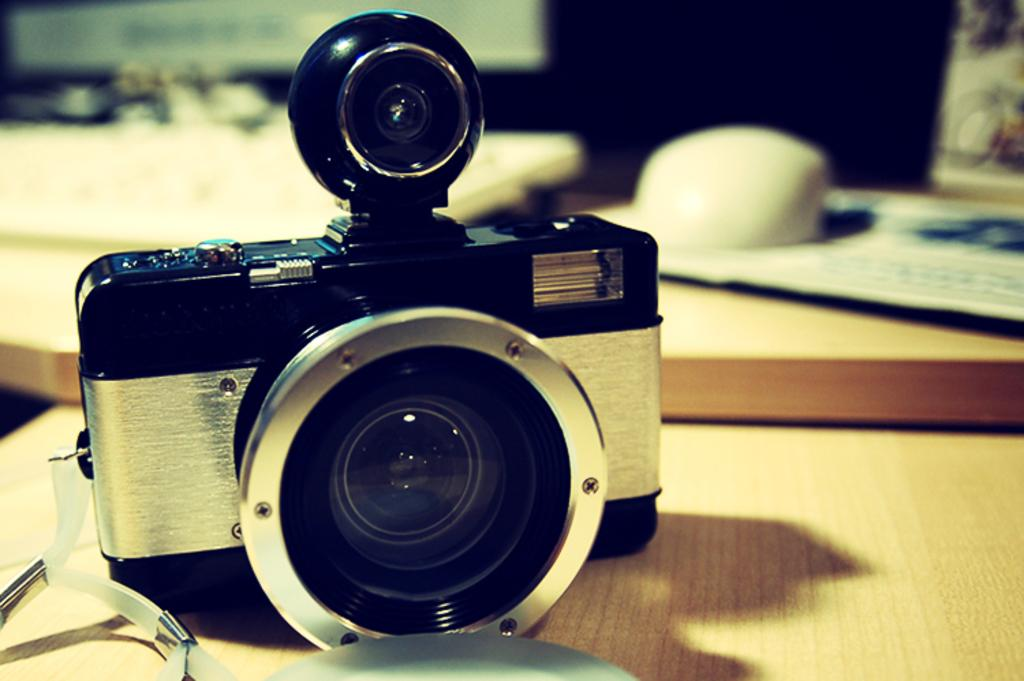What object is the main focus of the image? There is a camera in the image. Where is the camera located? The camera is placed on a table. What can be observed about the background in the image? The background of the camera is blurred. How many cats are visible in the image? There are no cats present in the image. What type of planes can be seen flying in the background of the image? There are no planes visible in the image; the background is blurred. 